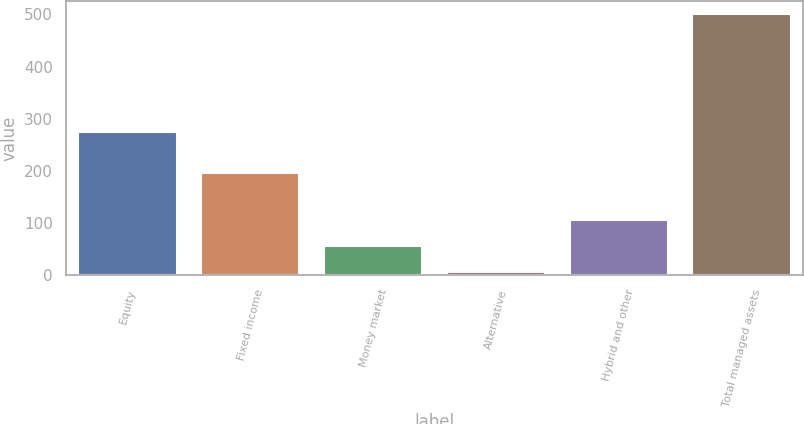<chart> <loc_0><loc_0><loc_500><loc_500><bar_chart><fcel>Equity<fcel>Fixed income<fcel>Money market<fcel>Alternative<fcel>Hybrid and other<fcel>Total managed assets<nl><fcel>275.3<fcel>196.4<fcel>55.84<fcel>6.4<fcel>105.28<fcel>500.8<nl></chart> 